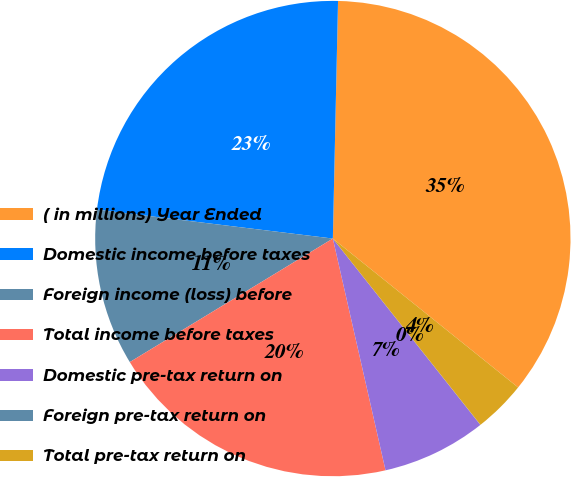<chart> <loc_0><loc_0><loc_500><loc_500><pie_chart><fcel>( in millions) Year Ended<fcel>Domestic income before taxes<fcel>Foreign income (loss) before<fcel>Total income before taxes<fcel>Domestic pre-tax return on<fcel>Foreign pre-tax return on<fcel>Total pre-tax return on<nl><fcel>35.43%<fcel>23.41%<fcel>10.64%<fcel>19.86%<fcel>7.1%<fcel>0.01%<fcel>3.56%<nl></chart> 